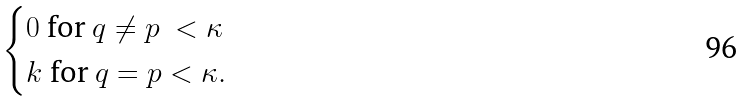<formula> <loc_0><loc_0><loc_500><loc_500>\begin{cases} 0 \ \text {for} \ q \neq p \ < \kappa \\ k \ \text {for} \ q = p < \kappa . \end{cases}</formula> 